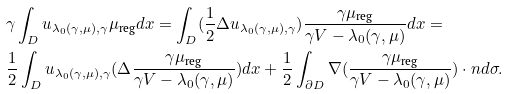<formula> <loc_0><loc_0><loc_500><loc_500>& \gamma \int _ { D } u _ { \lambda _ { 0 } ( \gamma , \mu ) , \gamma } \mu _ { \text {reg} } d x = \int _ { D } ( \frac { 1 } { 2 } \Delta u _ { \lambda _ { 0 } ( \gamma , \mu ) , \gamma } ) \frac { \gamma \mu _ { \text {reg} } } { \gamma V - \lambda _ { 0 } ( \gamma , \mu ) } d x = \\ & \frac { 1 } { 2 } \int _ { D } u _ { \lambda _ { 0 } ( \gamma , \mu ) , \gamma } ( \Delta \frac { \gamma \mu _ { \text {reg} } } { \gamma V - \lambda _ { 0 } ( \gamma , \mu ) } ) d x + \frac { 1 } { 2 } \int _ { \partial D } \nabla ( \frac { \gamma \mu _ { \text {reg} } } { \gamma V - \lambda _ { 0 } ( \gamma , \mu ) } ) \cdot n d \sigma .</formula> 